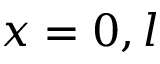Convert formula to latex. <formula><loc_0><loc_0><loc_500><loc_500>x = 0 , l</formula> 